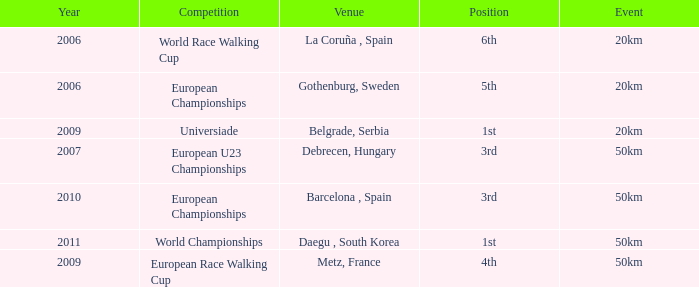What Position is listed against a Venue of Debrecen, Hungary 3rd. 